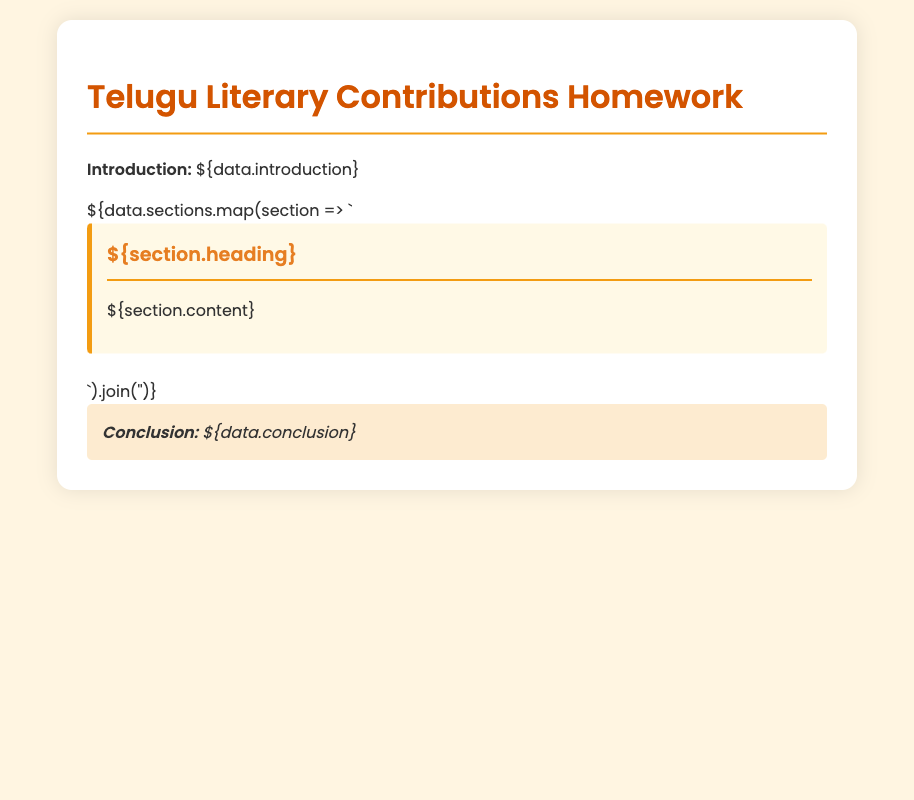What is the title of the homework document? The title can be found in the header section of the document, which states "Telugu Literary Contributions Homework."
Answer: Telugu Literary Contributions Homework What color is used for the section headings? The document specifies the color style for section headings showing that they are colored "#E67E22."
Answer: #E67E22 What type of background color is used for the body of the document? The style indicates that the background color of the body is "#FFF5E1."
Answer: #FFF5E1 How many sections are there in the homework document? The number of sections can be derived from the data provided, but since specific numbers are not included here, it generally refers to a count of individual sections.
Answer: Varies (depends on data) What is included in the conclusion of the document? The conclusion provides a summary or final thoughts on the literary contributions discussed throughout the sections.
Answer: Summary or final thoughts What is the font family used in the document? The style in the document states that the font family used is 'Poppins.'
Answer: Poppins What is the purpose of this homework document? The purpose is reflected in the introduction that discusses key contributions of Telugu scholars, poets, and writers.
Answer: Key contributions of Telugu scholars, poets, and writers What is the color of the border used for the sections? The document specifies that the left border of the sections is colored "#F39C12."
Answer: #F39C12 What is the margin size for the body of the document? The document specifies that the margin is set to "0 auto," indicating a centered layout.
Answer: Centered layout (0 auto) 